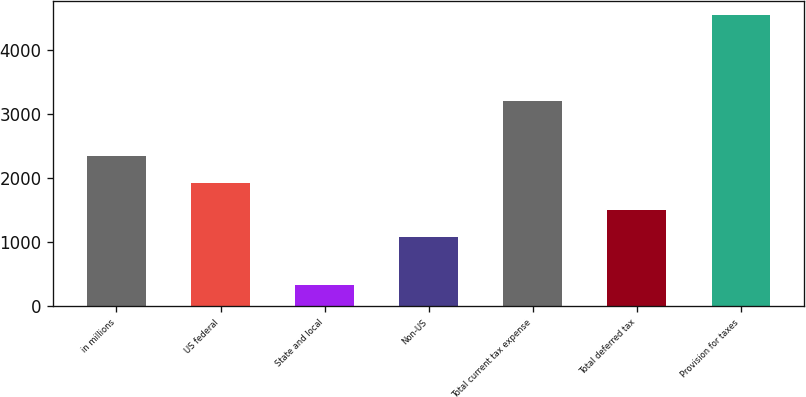<chart> <loc_0><loc_0><loc_500><loc_500><bar_chart><fcel>in millions<fcel>US federal<fcel>State and local<fcel>Non-US<fcel>Total current tax expense<fcel>Total deferred tax<fcel>Provision for taxes<nl><fcel>2346.9<fcel>1925.6<fcel>325<fcel>1083<fcel>3199<fcel>1504.3<fcel>4538<nl></chart> 